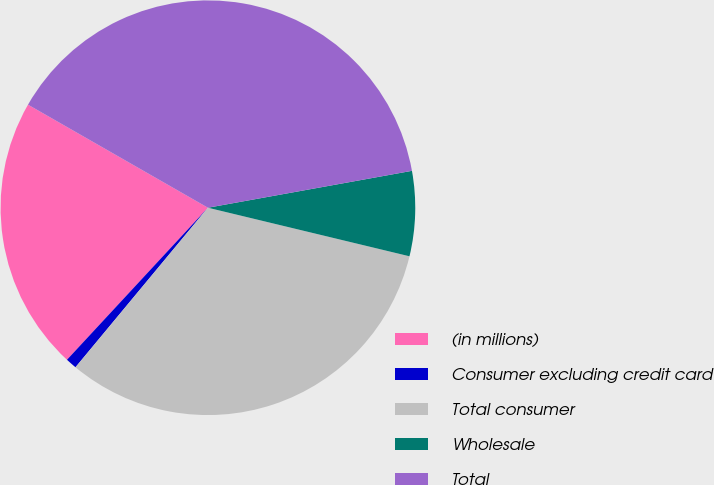<chart> <loc_0><loc_0><loc_500><loc_500><pie_chart><fcel>(in millions)<fcel>Consumer excluding credit card<fcel>Total consumer<fcel>Wholesale<fcel>Total<nl><fcel>21.38%<fcel>0.87%<fcel>32.26%<fcel>6.61%<fcel>38.87%<nl></chart> 